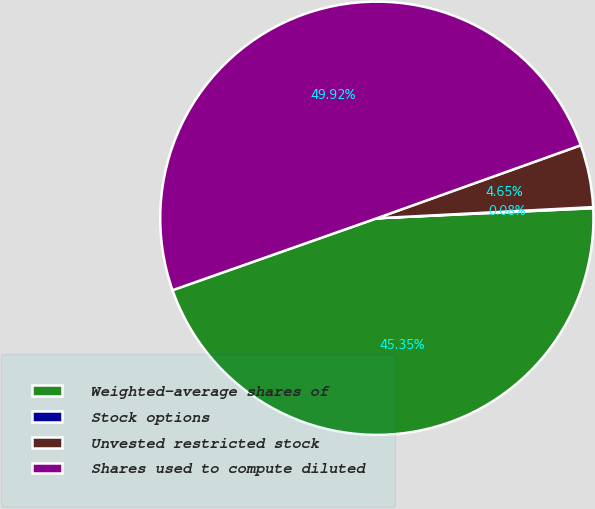Convert chart. <chart><loc_0><loc_0><loc_500><loc_500><pie_chart><fcel>Weighted-average shares of<fcel>Stock options<fcel>Unvested restricted stock<fcel>Shares used to compute diluted<nl><fcel>45.35%<fcel>0.08%<fcel>4.65%<fcel>49.92%<nl></chart> 